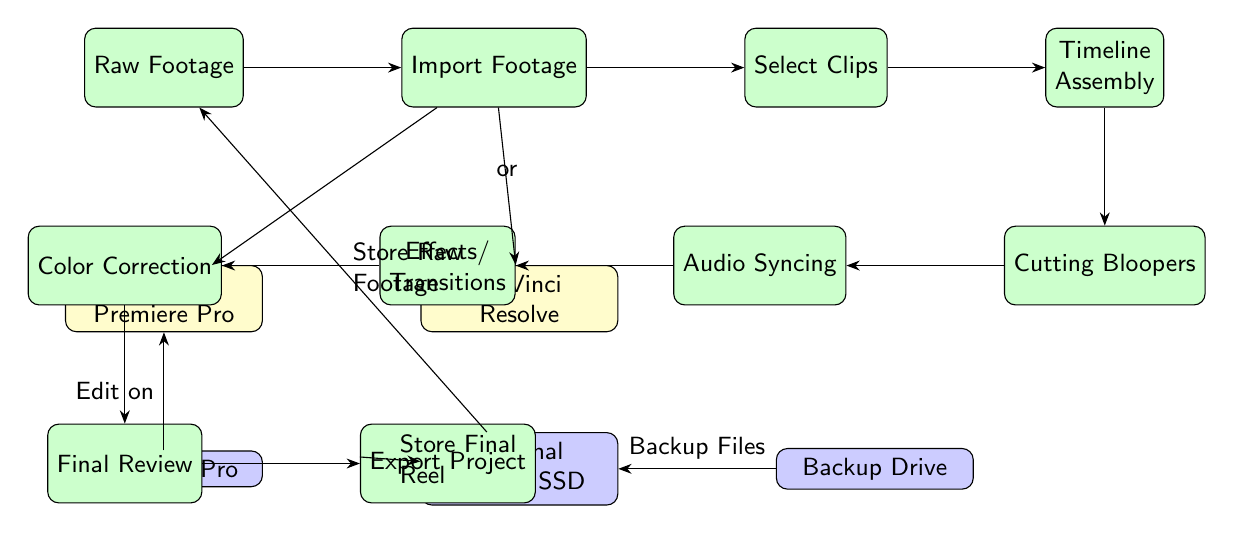What is the first process in the workflow? The first process in the workflow is depicted at the top of the diagram and is labeled as "Raw Footage." This indicates that the workflow begins with the collection of raw video material.
Answer: Raw Footage How many software tools are used in this video editing workflow? The diagram showcases two software tools located next to each other, labeled "Adobe Premiere Pro" and "DaVinci Resolve." Thus, there are two software tools in this workflow.
Answer: 2 What is the last process before the project is exported? Looking at the flow of processes in the diagram, the last step before exporting is a process labeled "Final Review," which suggests that the project is reviewed for any changes before the final export.
Answer: Final Review Which hardware is used for editing? According to the diagram, there is a hardware node directly labeled "MacBook Pro," indicating that it is the designated hardware used for editing in this workflow.
Answer: MacBook Pro What action takes place before "Cutting Bloopers"? In the workflow, the process "Timeline Assembly" precedes "Cutting Bloopers." It shows that before any cutting is done, the clips are compiled into a timeline.
Answer: Timeline Assembly What are the effects of the "Backup Drive" in the diagram? The "Backup Drive" is indicated to connect to the "Storage," suggesting that it serves the purpose of backing up files stored in this workflow, thereby providing data redundancy and security.
Answer: Backup Files How does the workflow handle raw footage storage? The diagram shows that raw footage is stored on an "External HDD / SSD," which connects to the "Raw Footage" process, indicating that the storage medium is essential for holding the initial footage.
Answer: Store Raw Footage Which process follows "Audio Syncing"? Following "Audio Syncing," the next process as indicated by the directional arrow in the diagram is "Effects/Transitions," meaning that after syncing audio, effects and transitions are applied.
Answer: Effects/Transitions 